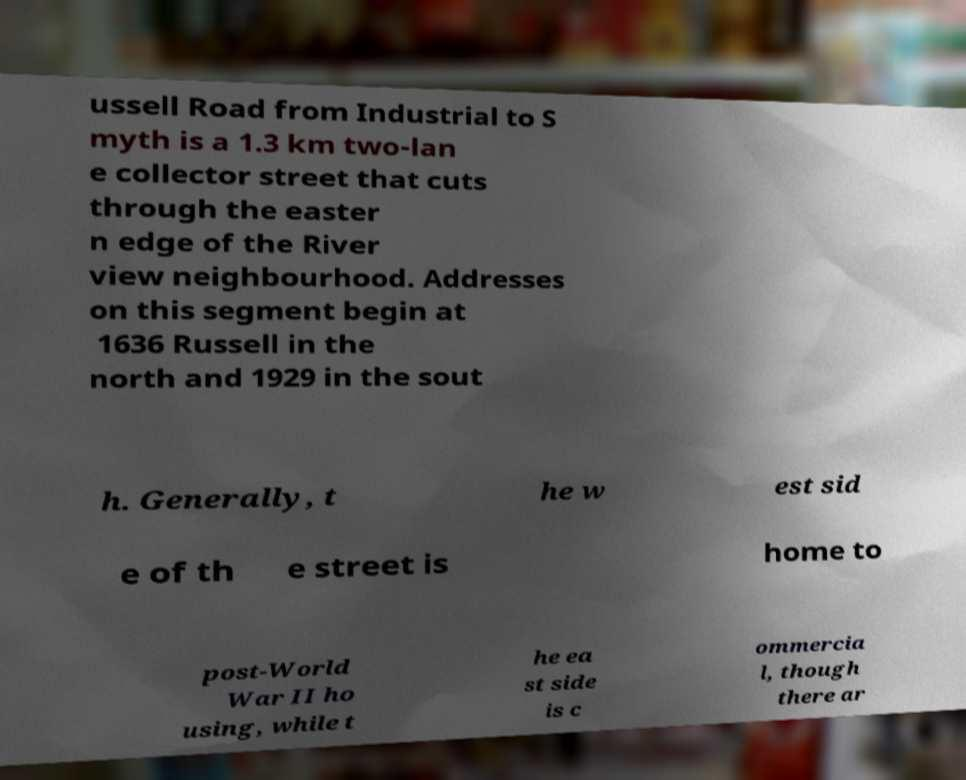Could you extract and type out the text from this image? ussell Road from Industrial to S myth is a 1.3 km two-lan e collector street that cuts through the easter n edge of the River view neighbourhood. Addresses on this segment begin at 1636 Russell in the north and 1929 in the sout h. Generally, t he w est sid e of th e street is home to post-World War II ho using, while t he ea st side is c ommercia l, though there ar 